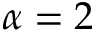<formula> <loc_0><loc_0><loc_500><loc_500>\alpha = 2</formula> 